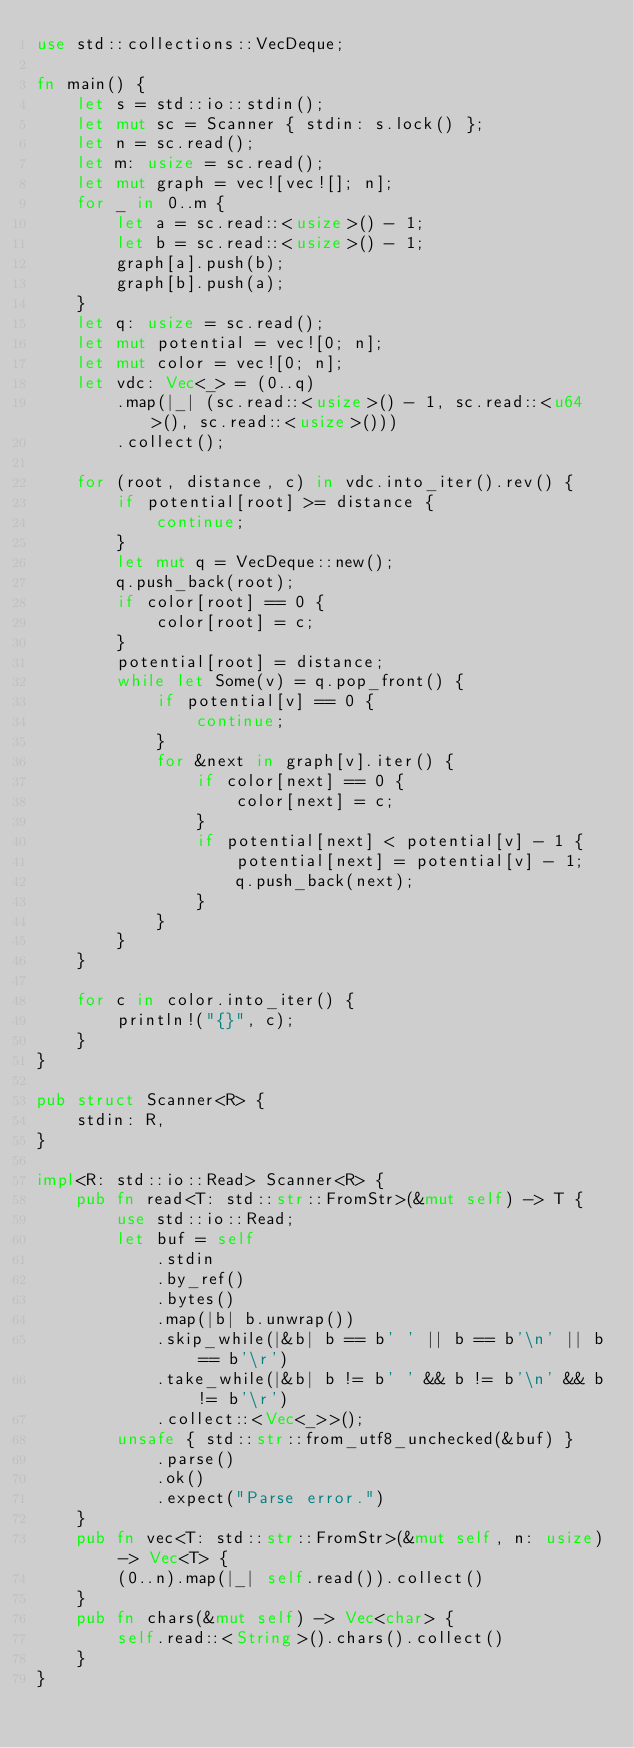<code> <loc_0><loc_0><loc_500><loc_500><_Rust_>use std::collections::VecDeque;

fn main() {
    let s = std::io::stdin();
    let mut sc = Scanner { stdin: s.lock() };
    let n = sc.read();
    let m: usize = sc.read();
    let mut graph = vec![vec![]; n];
    for _ in 0..m {
        let a = sc.read::<usize>() - 1;
        let b = sc.read::<usize>() - 1;
        graph[a].push(b);
        graph[b].push(a);
    }
    let q: usize = sc.read();
    let mut potential = vec![0; n];
    let mut color = vec![0; n];
    let vdc: Vec<_> = (0..q)
        .map(|_| (sc.read::<usize>() - 1, sc.read::<u64>(), sc.read::<usize>()))
        .collect();

    for (root, distance, c) in vdc.into_iter().rev() {
        if potential[root] >= distance {
            continue;
        }
        let mut q = VecDeque::new();
        q.push_back(root);
        if color[root] == 0 {
            color[root] = c;
        }
        potential[root] = distance;
        while let Some(v) = q.pop_front() {
            if potential[v] == 0 {
                continue;
            }
            for &next in graph[v].iter() {
                if color[next] == 0 {
                    color[next] = c;
                }
                if potential[next] < potential[v] - 1 {
                    potential[next] = potential[v] - 1;
                    q.push_back(next);
                }
            }
        }
    }

    for c in color.into_iter() {
        println!("{}", c);
    }
}

pub struct Scanner<R> {
    stdin: R,
}

impl<R: std::io::Read> Scanner<R> {
    pub fn read<T: std::str::FromStr>(&mut self) -> T {
        use std::io::Read;
        let buf = self
            .stdin
            .by_ref()
            .bytes()
            .map(|b| b.unwrap())
            .skip_while(|&b| b == b' ' || b == b'\n' || b == b'\r')
            .take_while(|&b| b != b' ' && b != b'\n' && b != b'\r')
            .collect::<Vec<_>>();
        unsafe { std::str::from_utf8_unchecked(&buf) }
            .parse()
            .ok()
            .expect("Parse error.")
    }
    pub fn vec<T: std::str::FromStr>(&mut self, n: usize) -> Vec<T> {
        (0..n).map(|_| self.read()).collect()
    }
    pub fn chars(&mut self) -> Vec<char> {
        self.read::<String>().chars().collect()
    }
}
</code> 